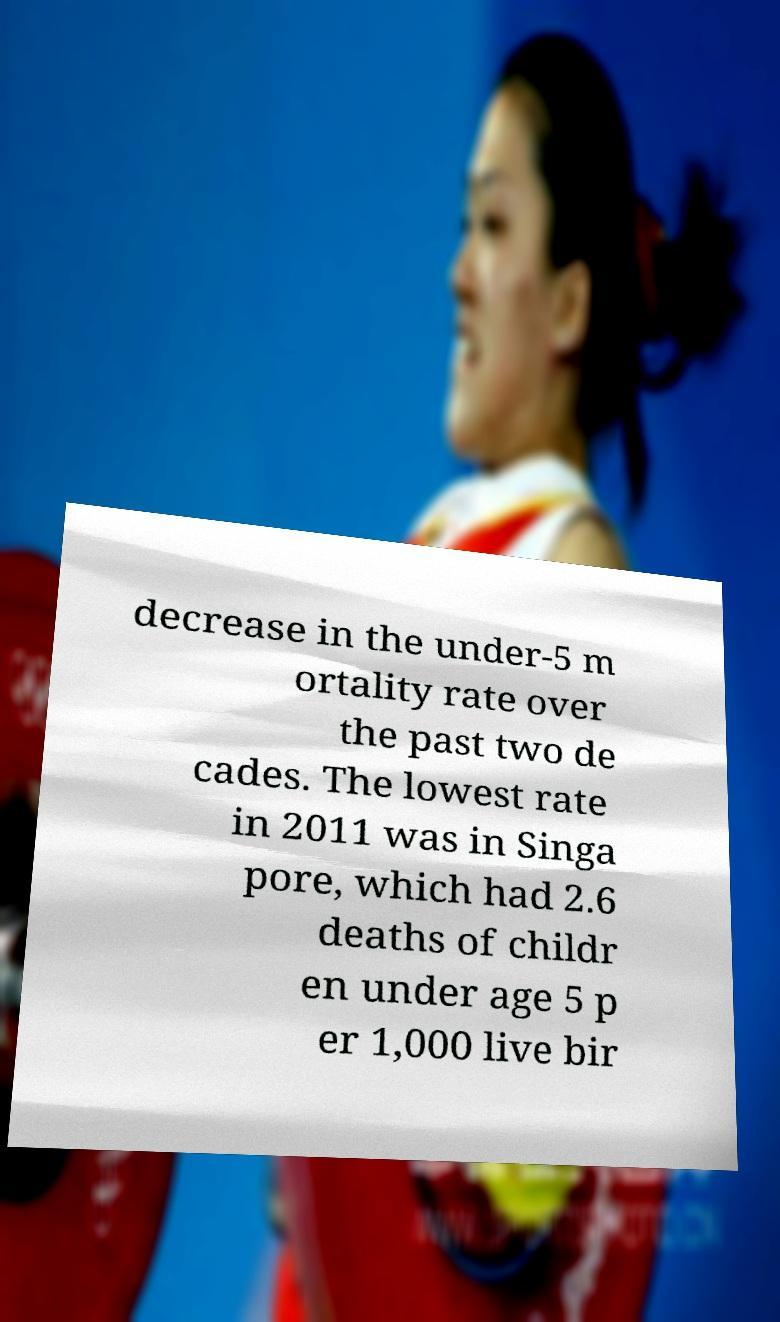Can you accurately transcribe the text from the provided image for me? decrease in the under-5 m ortality rate over the past two de cades. The lowest rate in 2011 was in Singa pore, which had 2.6 deaths of childr en under age 5 p er 1,000 live bir 